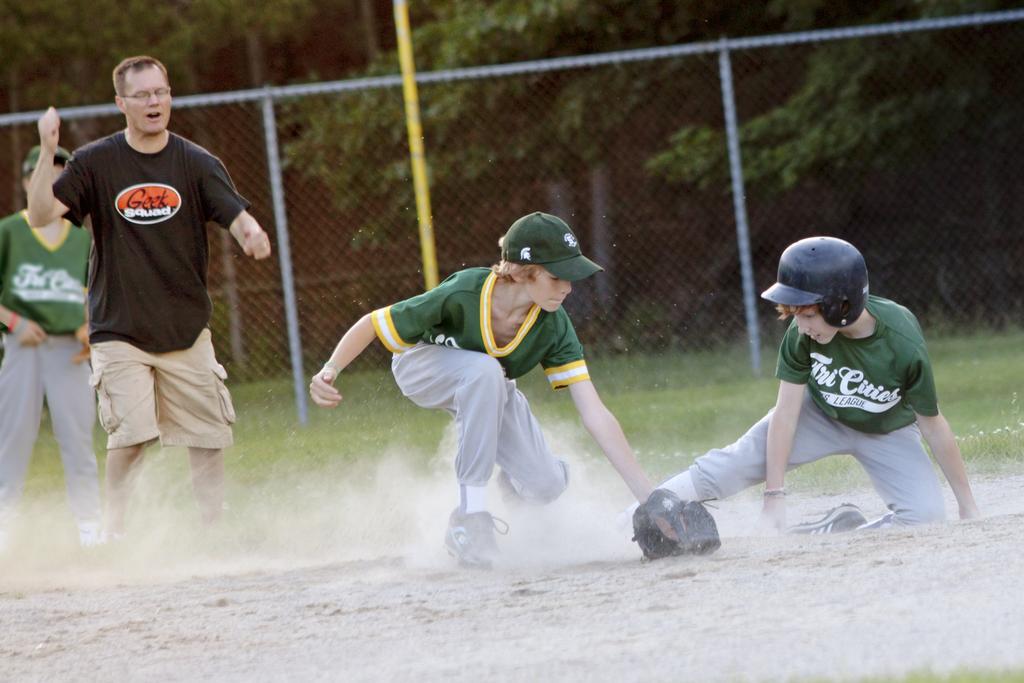Please provide a concise description of this image. In this image we can see two boys are playing. They are wearing green color t-shirt and pant. We can see two person, pole, fencing and trees in the background. 